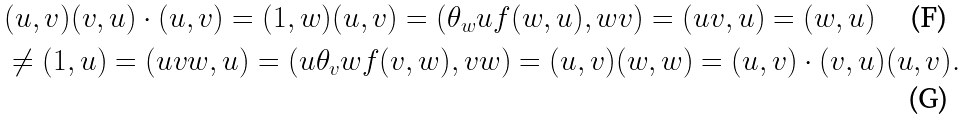Convert formula to latex. <formula><loc_0><loc_0><loc_500><loc_500>& ( u , v ) ( v , u ) \cdot ( u , v ) = ( 1 , w ) ( u , v ) = ( \theta _ { w } u f ( w , u ) , w v ) = ( u v , u ) = ( w , u ) \\ & \ne ( 1 , u ) = ( u v w , u ) = ( u \theta _ { v } w f ( v , w ) , v w ) = ( u , v ) ( w , w ) = ( u , v ) \cdot ( v , u ) ( u , v ) .</formula> 